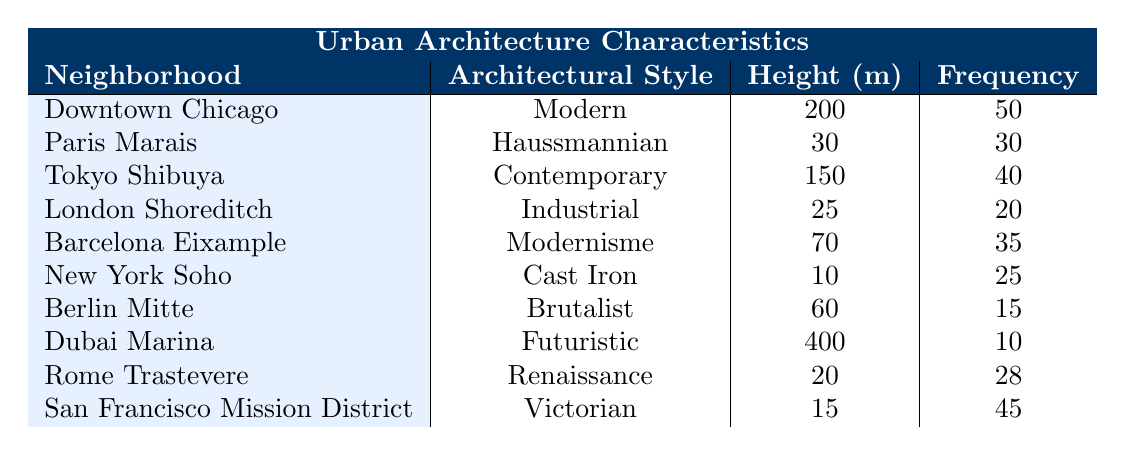What is the height of the building in Downtown Chicago? The table lists the height of the building in Downtown Chicago under the "Height (meters)" column, which shows 200 meters.
Answer: 200 meters Which architectural style has the highest frequency and what is that frequency? Looking through the "Frequency" column, the highest value is 50, which corresponds to the "Modern" architectural style in Downtown Chicago.
Answer: Modern, 50 What is the average height of the buildings in the listed neighborhoods? The total height of all the buildings is calculated as (200 + 30 + 150 + 25 + 70 + 10 + 60 + 400 + 20 + 15) = 980 meters. There are 10 neighborhoods, so the average height is 980/10 = 98.
Answer: 98 meters Is there any neighborhood with a height greater than 300 meters? By checking the "Height (meters)" column, the maximum height listed is 400 meters in Dubai Marina, confirming that at least one neighborhood exceeds 300 meters.
Answer: Yes What is the total frequency of buildings with a height of 20 meters or lower? Filtering for heights of 20 meters or lower, we find New York Soho (10 meters, frequency 25), London Shoreditch (25 meters, frequency 20), and Rome Trastevere (20 meters, frequency 28). Thus, total frequency is 25 + 20 + 28 = 73.
Answer: 73 Which architectural style has a frequency lower than 20 and what is it? Searching through the "Frequency" column, only Berlin Mitte has a frequency of 15 in the Brutalist style, which is the only architectural style that meets this criterion.
Answer: Brutalist, 15 What is the difference in frequency between Modern and Victorian architectural styles? The frequency of Modern is 50 and for Victorian it is 45. The difference is calculated as 50 - 45 = 5.
Answer: 5 Are there more buildings in Paris Marais or in Barcelona Eixample? The frequency for Paris Marais is 30 and for Barcelona Eixample is 35. Since 35 is greater than 30, Barcelona Eixample has more buildings than Paris Marais.
Answer: Barcelona Eixample What percentage of the total height do the buildings in Tokyo Shibuya represent? First, find the total height (980 meters). Tokyo Shibuya has a height of 150 meters. The percentage is (150 / 980) * 100 ≈ 15.31%.
Answer: 15.31% 